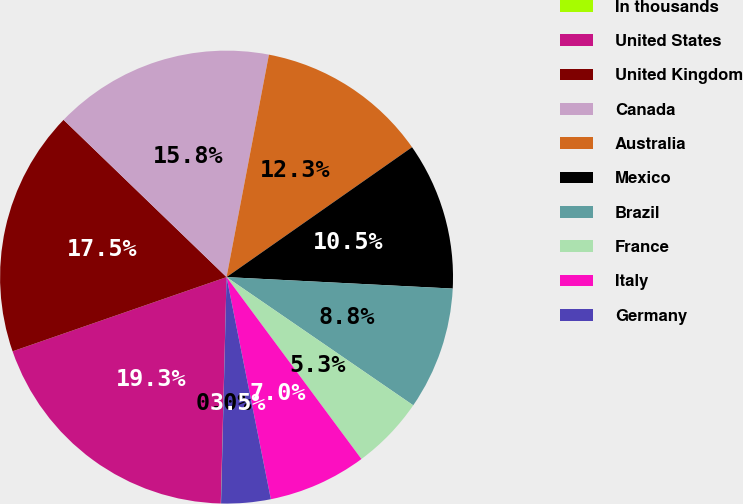<chart> <loc_0><loc_0><loc_500><loc_500><pie_chart><fcel>In thousands<fcel>United States<fcel>United Kingdom<fcel>Canada<fcel>Australia<fcel>Mexico<fcel>Brazil<fcel>France<fcel>Italy<fcel>Germany<nl><fcel>0.02%<fcel>19.28%<fcel>17.53%<fcel>15.78%<fcel>12.28%<fcel>10.53%<fcel>8.77%<fcel>5.27%<fcel>7.02%<fcel>3.52%<nl></chart> 